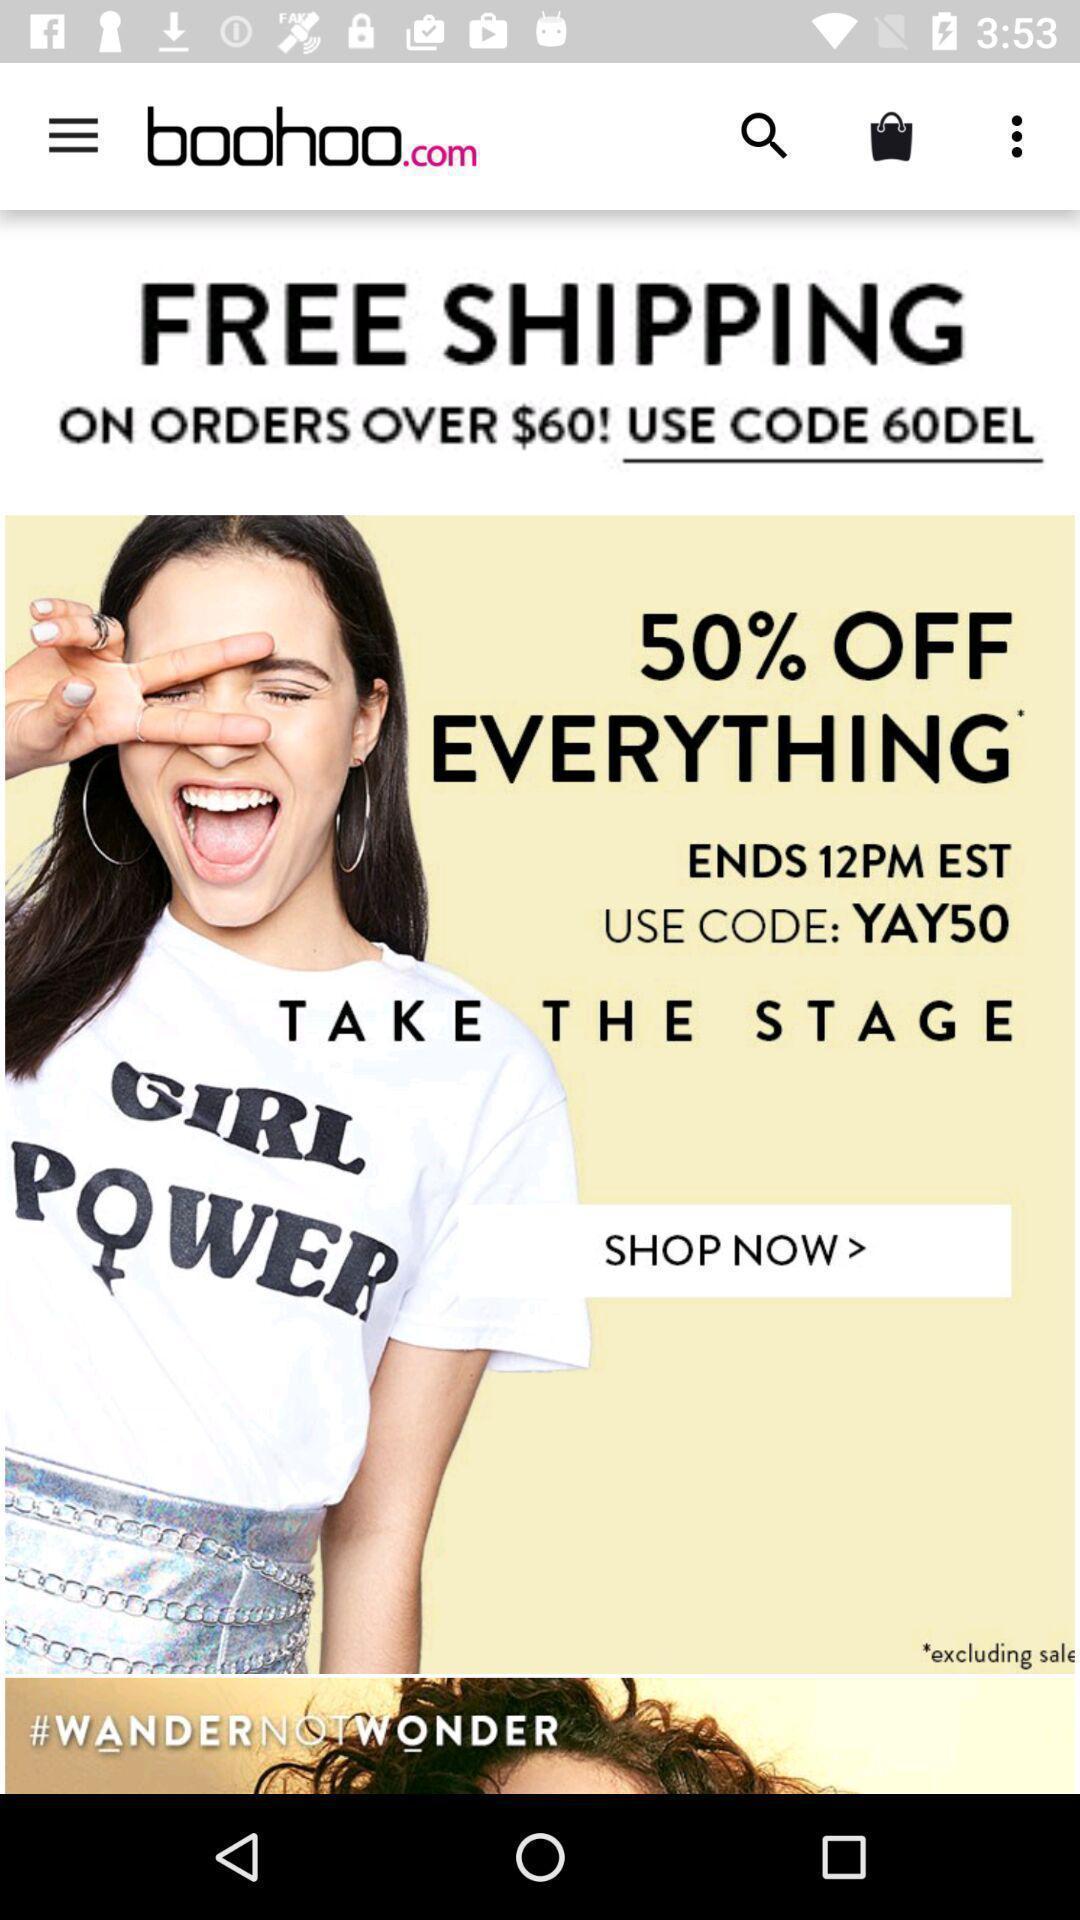Explain what's happening in this screen capture. Screen shows multiple deals in shopping app. 